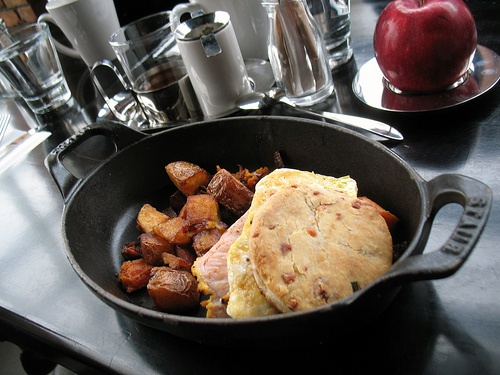Describe the objects in this image and their specific colors. I can see dining table in black, gray, darkgray, lightgray, and maroon tones, sandwich in maroon and tan tones, apple in maroon, black, and brown tones, cup in maroon, black, gray, darkgray, and lightgray tones, and cup in maroon, gray, darkgray, black, and lightgray tones in this image. 